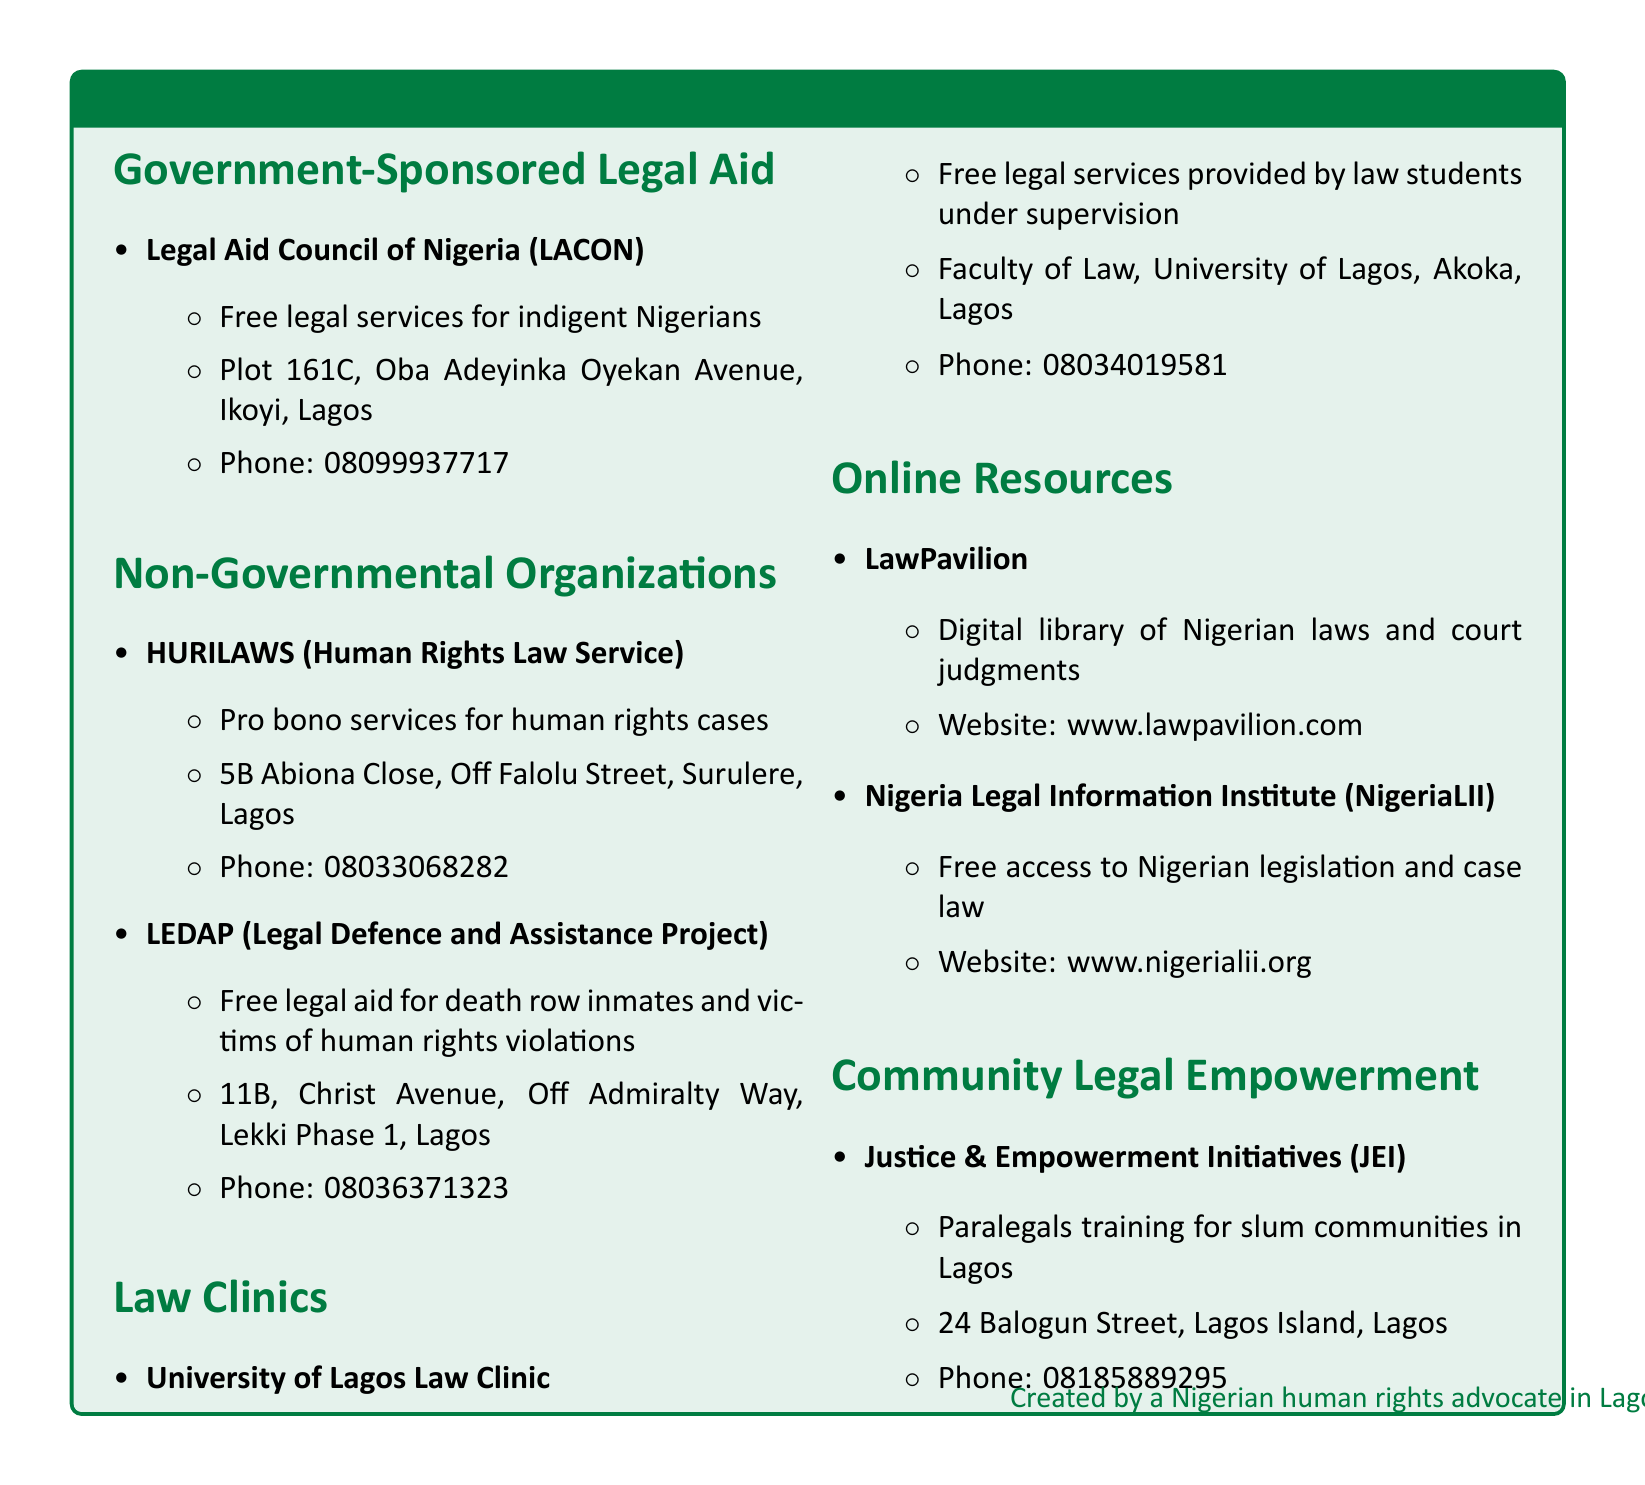What is the address of the Legal Aid Council of Nigeria? The address is specified in the document under Government-Sponsored Legal Aid, which states that it is located at Plot 161C, Oba Adeyinka Oyekan Avenue, Ikoyi, Lagos.
Answer: Plot 161C, Oba Adeyinka Oyekan Avenue, Ikoyi, Lagos How many phone numbers are listed for NGOs in the document? By counting the phone numbers provided for each NGO listed, we find three unique phone numbers.
Answer: Three What organization provides pro bono services for human rights cases? The document mentions HURILAWS (Human Rights Law Service) as the organization that offers pro bono services specifically for human rights cases.
Answer: HURILAWS Which law clinic offers free legal services by law students? The University of Lagos Law Clinic is the law clinic specified in the document that offers free legal services provided by law students under supervision.
Answer: University of Lagos Law Clinic What digital library is mentioned in the online resources? The document lists LawPavilion as the digital library of Nigerian laws and court judgments.
Answer: LawPavilion What type of training does Justice & Empowerment Initiatives provide? The document states that Justice & Empowerment Initiatives offers paralegals training for slum communities in Lagos.
Answer: Paralegals training What is the phone number for LEDAP? The document provides the phone number for LEDAP, which is indicated under the NGO section.
Answer: 08036371323 What kind of access does Nigeria Legal Information Institute provide? According to the document, the Nigeria Legal Information Institute offers free access to Nigerian legislation and case law.
Answer: Free access to Nigerian legislation and case law What is the contact phone number for the University of Lagos Law Clinic? The document specifies that the contact phone number for the University of Lagos Law Clinic is 08034019581.
Answer: 08034019581 